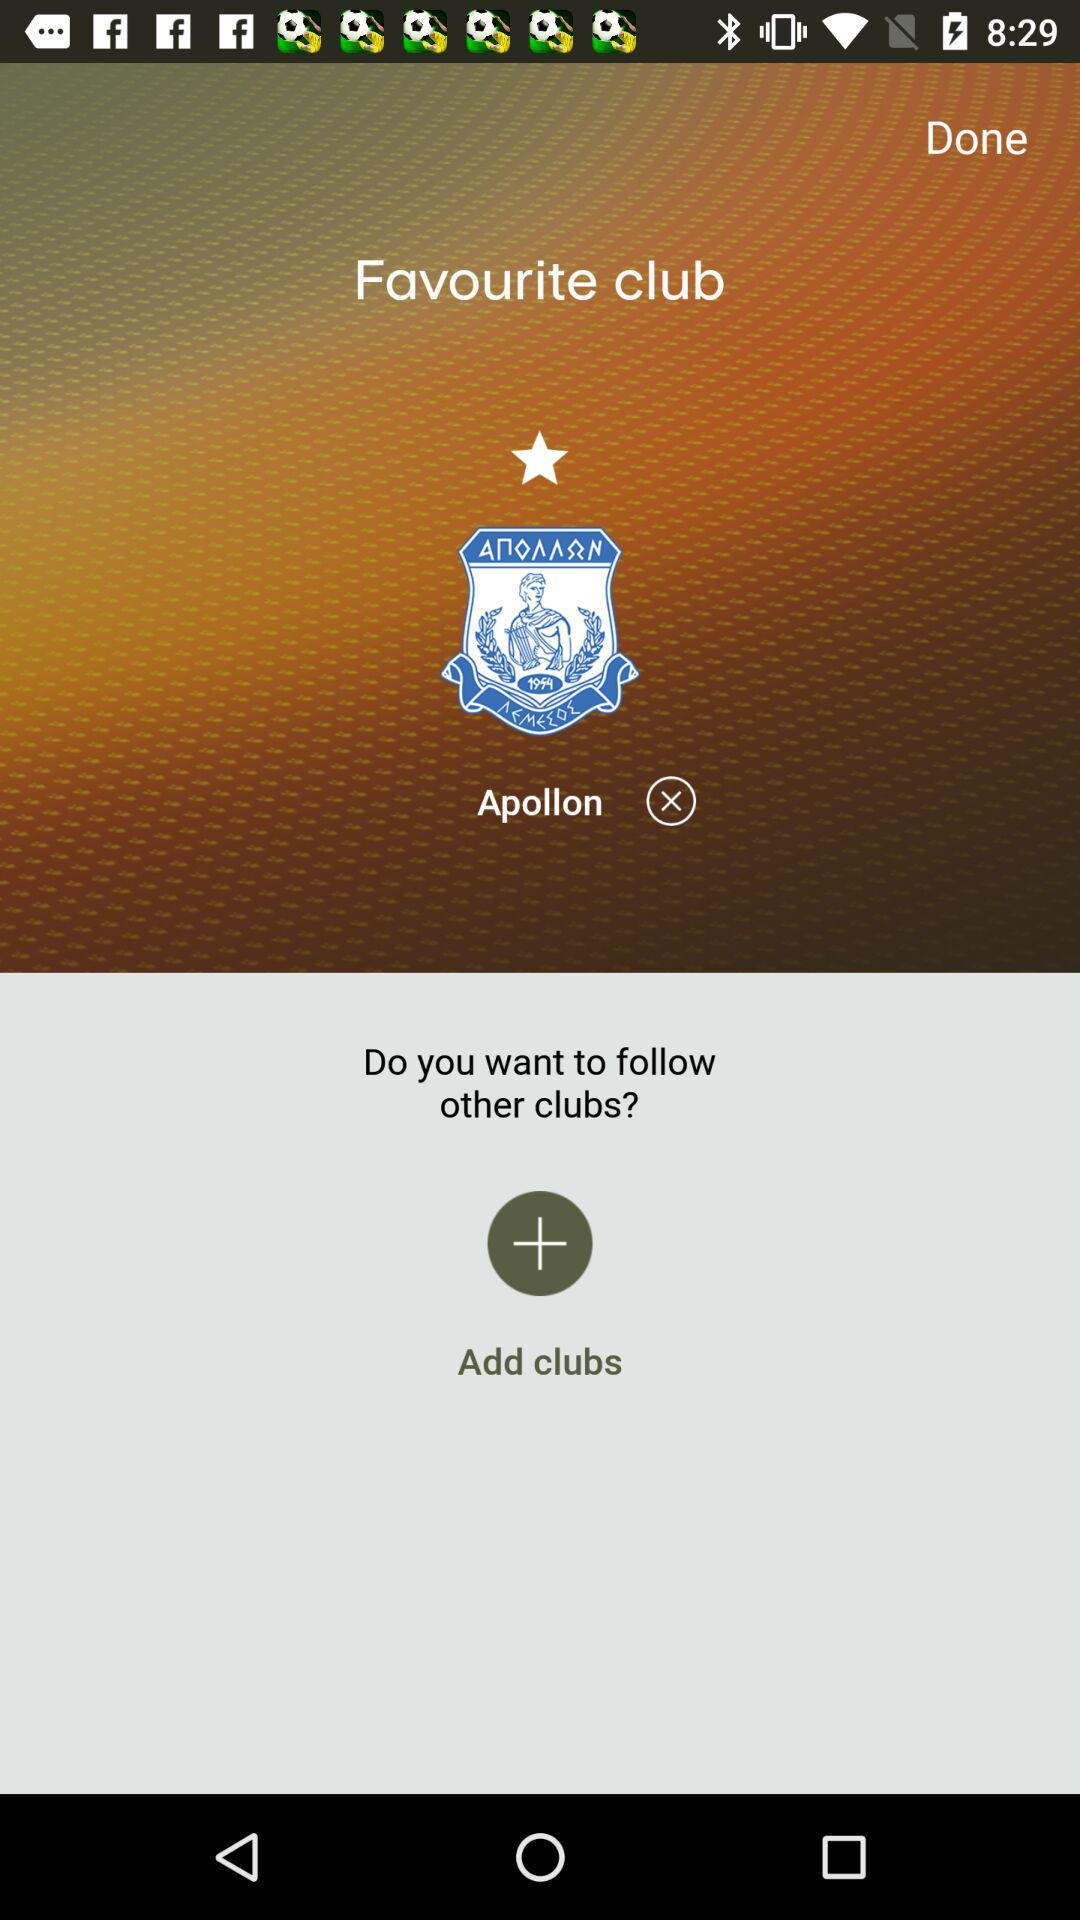What are the names of the added clubs?
When the provided information is insufficient, respond with <no answer>. <no answer> 